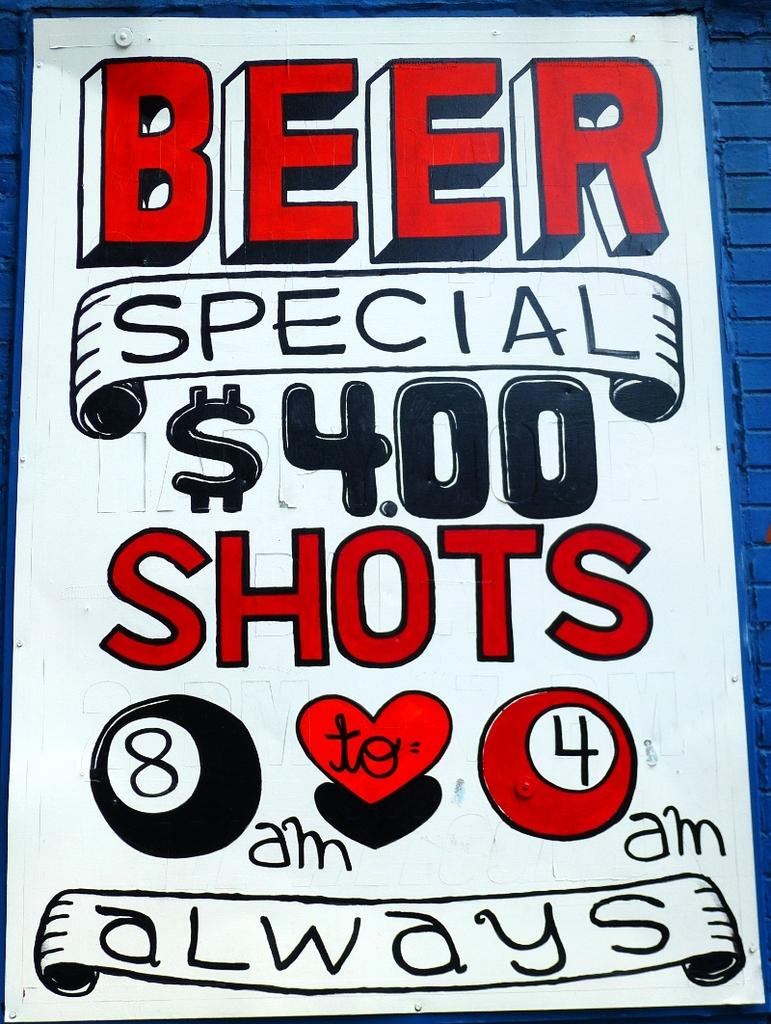<image>
Provide a brief description of the given image. A sign advertising a Berr Special and 4.00 shots. 